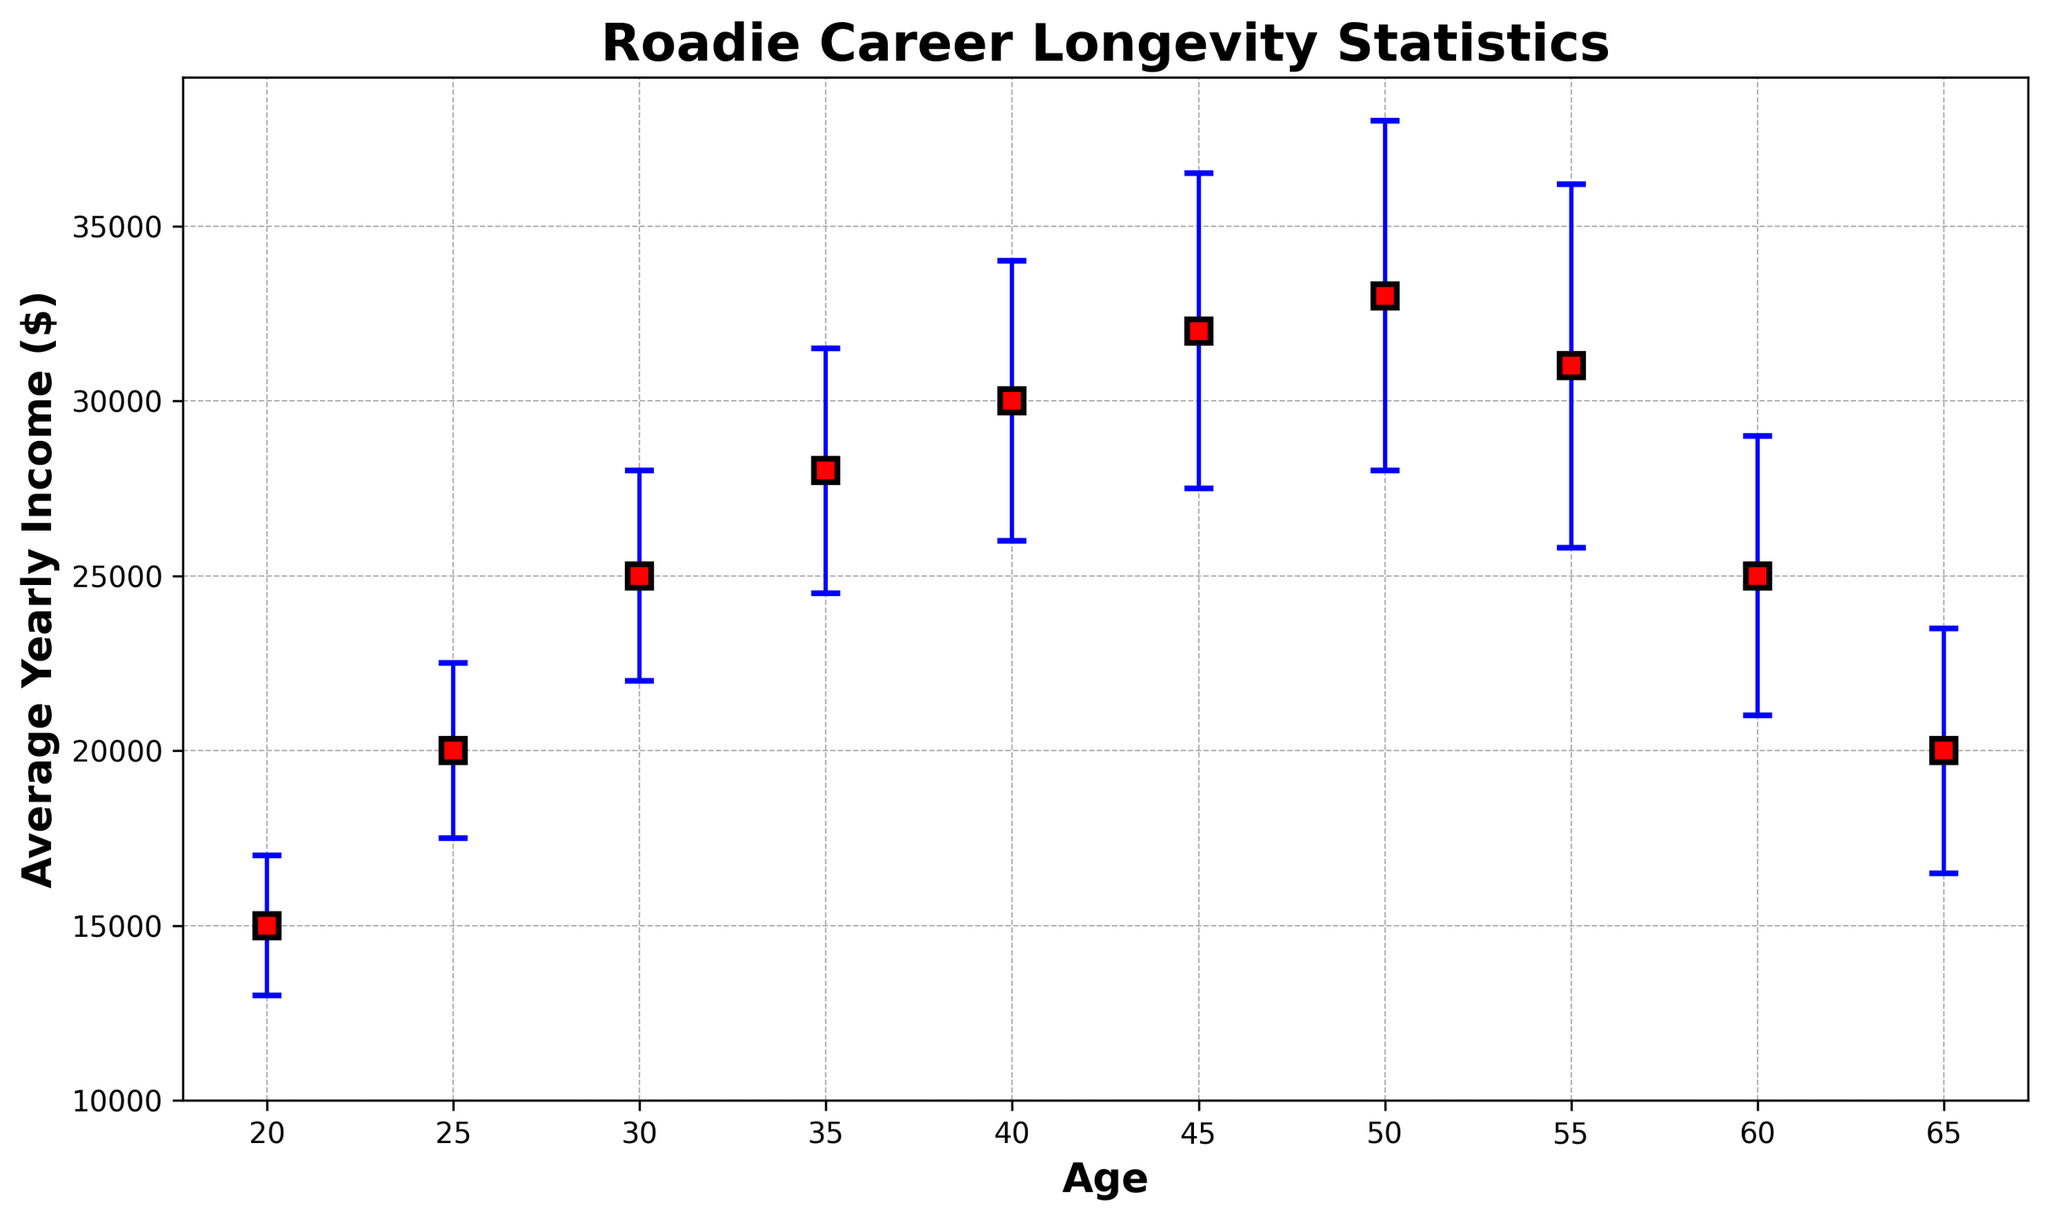Which age group has the highest average yearly income? By looking at the plot, find the point with the highest y-axis value, which corresponds to the yearly income. The highest point on the y-axis is at age 50.
Answer: 50 What is the difference in average yearly income between ages 25 and 55? Locate the average yearly incomes for ages 25 and 55 on the plot. The average yearly income at age 25 is $20,000, and at age 55, it is $31,000. The difference is $31,000 - $20,000.
Answer: $11,000 Which age group has the largest variability in yearly income? By examining the lengths of the error bars (blue lines), identify the age group with the longest error bar. Age 55 has the longest error bar, indicating the most variability.
Answer: 55 What is the trend in average yearly income as age increases from 20 to 50? Observe the overall direction of the points from age 20 to 50 on the plot. The trend shows a consistent increase in average yearly income from age 20 to 50.
Answer: Increasing Between which two consecutive age groups is the drop in average yearly income the greatest? Compare the differences in average yearly income for consecutive age groups. The largest drop occurs between ages 55 and 60 (from $31,000 to $25,000), which is a decrease of $6,000.
Answer: 55 to 60 Estimate the average yearly income for age 45 based on the plot. Locate the data point for age 45 on the plot. The y-axis value at age 45 is approximately $32,000.
Answer: $32,000 How does the average yearly income at age 60 compare to that at age 30? Find the average yearly incomes for ages 60 and 30 on the plot. The income at age 60 is $25,000, and at age 30, it is $25,000, indicating they are equal.
Answer: Equal What can you infer about the yearly income variability for roadies around age 40 compared to age 20? Compare the lengths of the error bars for ages 40 and 20. The error bar at age 40 is longer than that at age 20, indicating greater variability in income at age 40.
Answer: Variability is greater at age 40 Identify the y-values (average yearly incomes) for ages where the plot shows the lowest incomes. Locate the lowest points on the y-axis. The lowest average yearly incomes occur at ages 20 and 65, with y-values around $15,000 and $20,000 respectively.
Answer: $15,000 and $20,000 